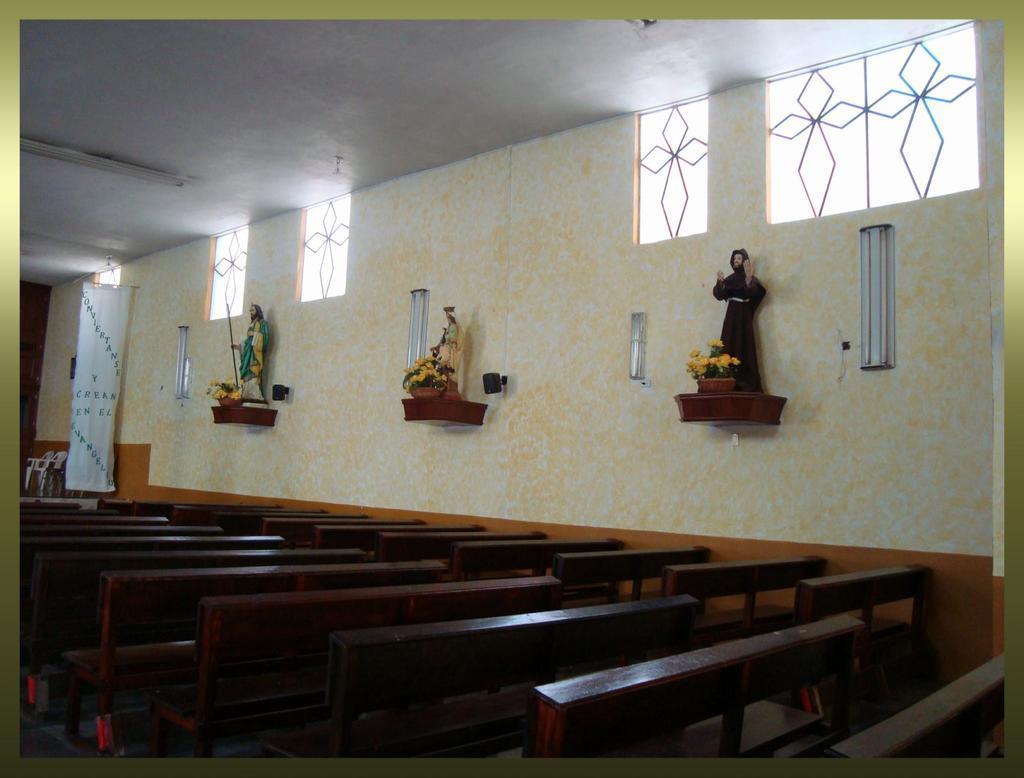Can you describe this image briefly? In the picture I can see few benches which are in brown color and there are few statues attached to the wall in the background and there is are few chairs and some other objects in the left corner. 